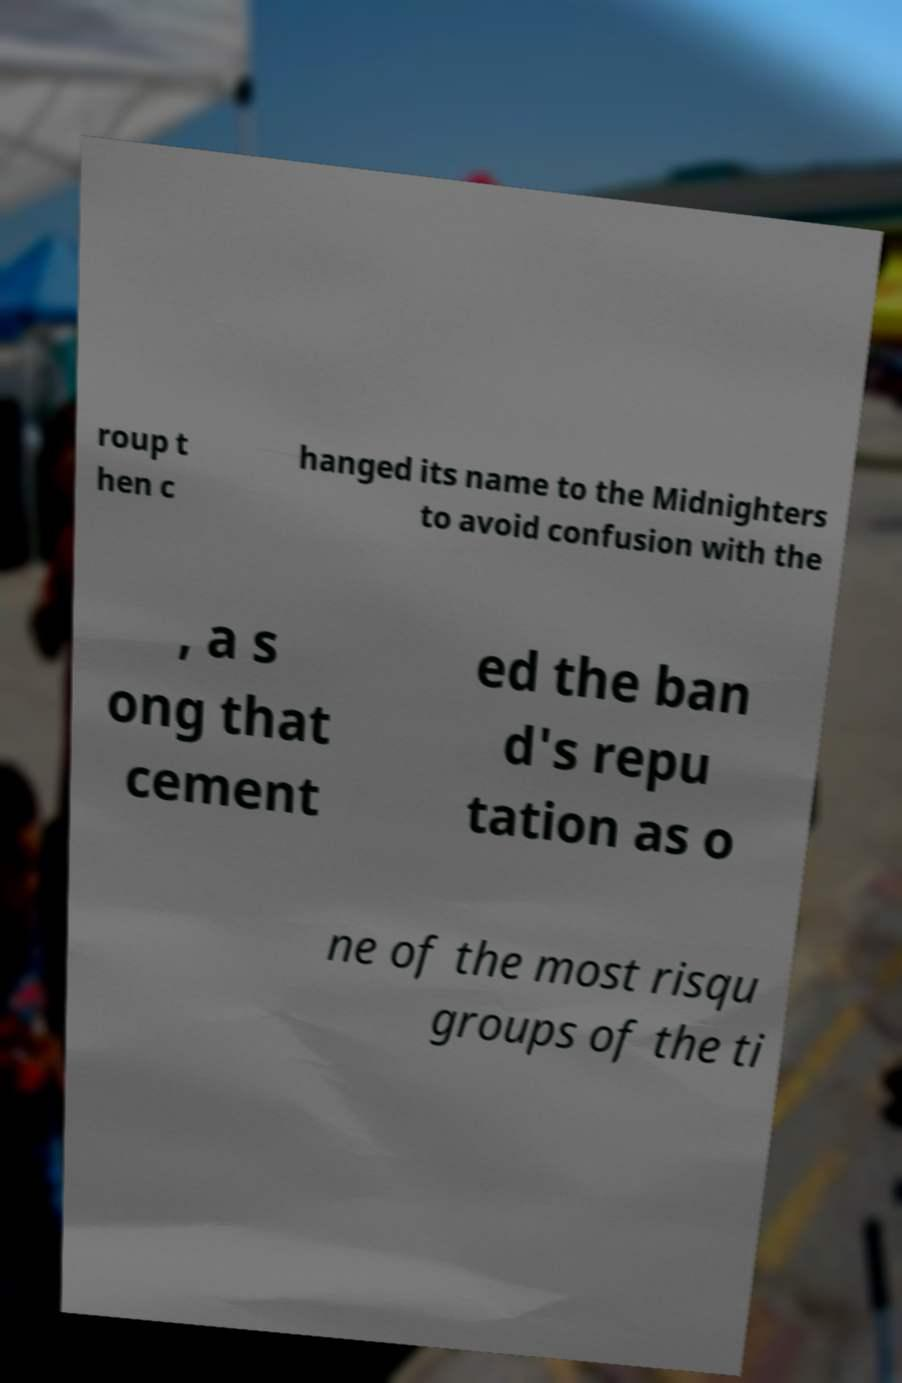I need the written content from this picture converted into text. Can you do that? roup t hen c hanged its name to the Midnighters to avoid confusion with the , a s ong that cement ed the ban d's repu tation as o ne of the most risqu groups of the ti 